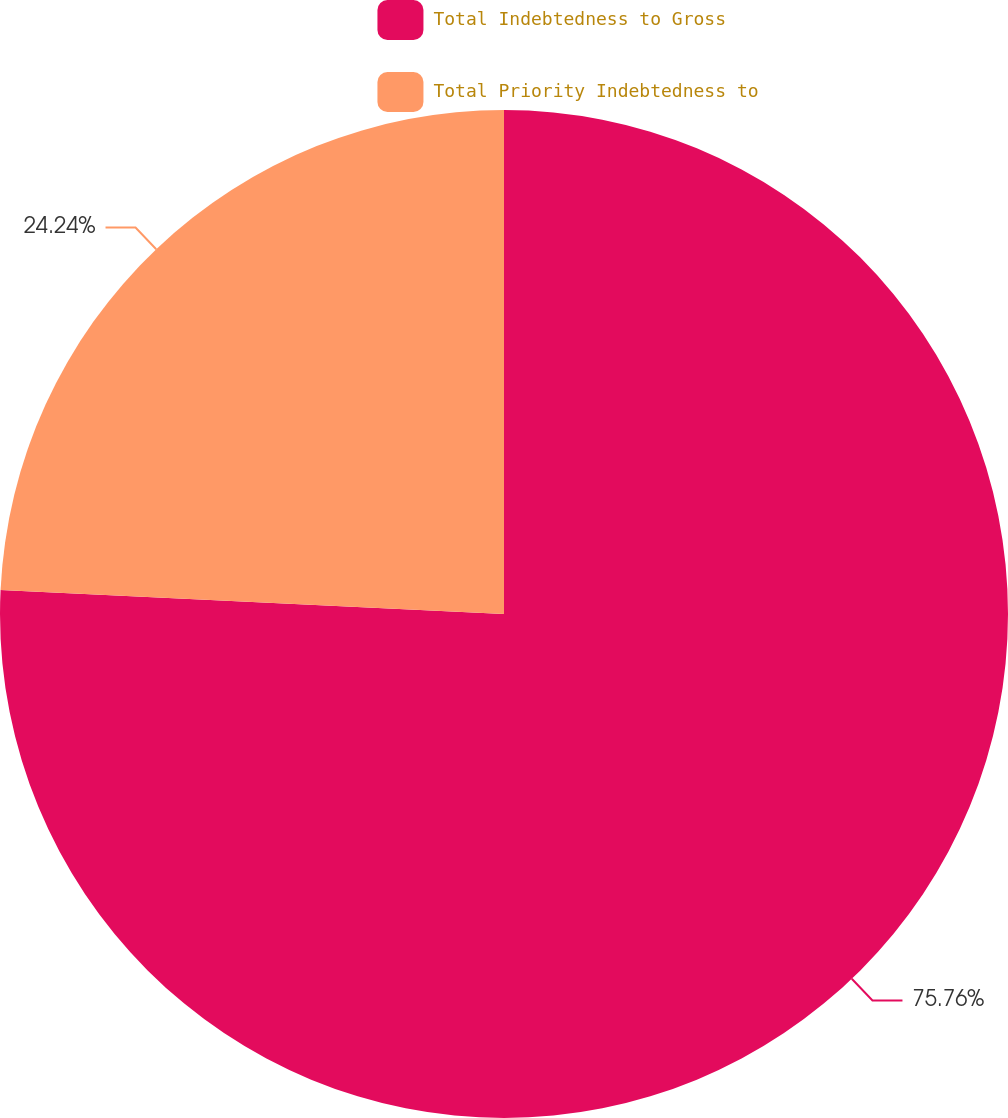Convert chart to OTSL. <chart><loc_0><loc_0><loc_500><loc_500><pie_chart><fcel>Total Indebtedness to Gross<fcel>Total Priority Indebtedness to<nl><fcel>75.76%<fcel>24.24%<nl></chart> 